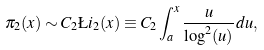Convert formula to latex. <formula><loc_0><loc_0><loc_500><loc_500>\pi _ { 2 } ( x ) \sim C _ { 2 } \L i _ { 2 } ( x ) \equiv C _ { 2 } \int _ { a } ^ { x } \frac { u } { \log ^ { 2 } ( u ) } d u ,</formula> 